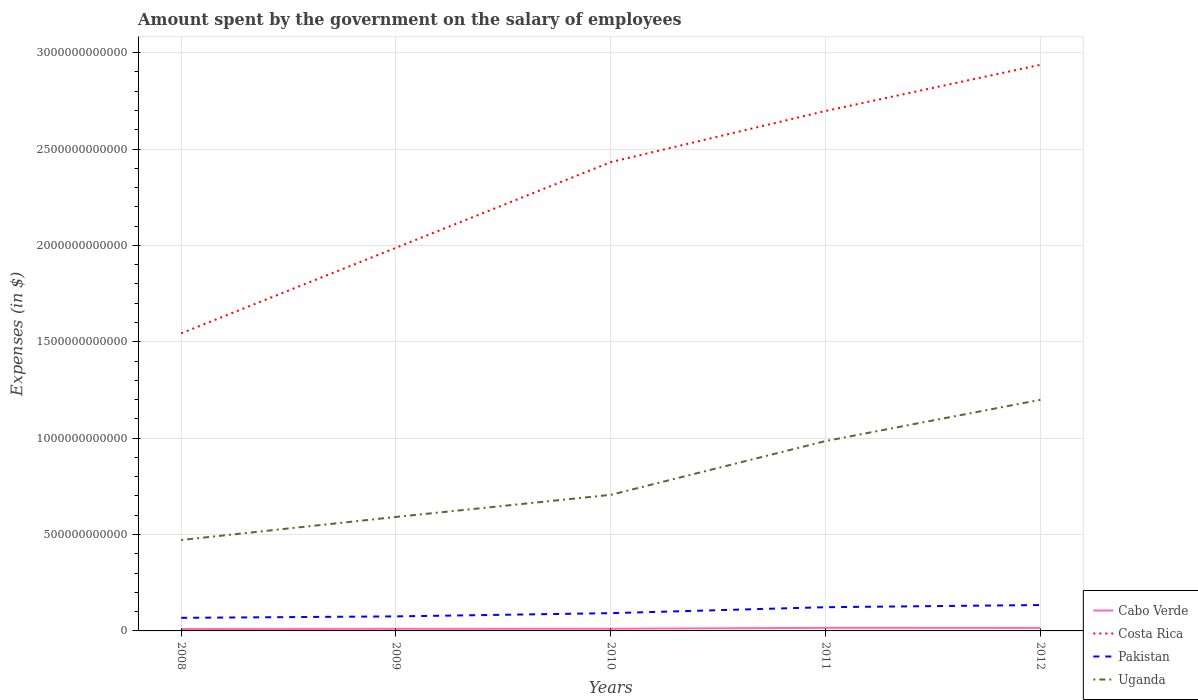How many different coloured lines are there?
Offer a very short reply. 4. Across all years, what is the maximum amount spent on the salary of employees by the government in Pakistan?
Provide a short and direct response. 6.79e+1. In which year was the amount spent on the salary of employees by the government in Costa Rica maximum?
Offer a very short reply. 2008. What is the total amount spent on the salary of employees by the government in Costa Rica in the graph?
Provide a short and direct response. -8.88e+11. What is the difference between the highest and the second highest amount spent on the salary of employees by the government in Uganda?
Give a very brief answer. 7.27e+11. Is the amount spent on the salary of employees by the government in Costa Rica strictly greater than the amount spent on the salary of employees by the government in Uganda over the years?
Offer a terse response. No. What is the difference between two consecutive major ticks on the Y-axis?
Make the answer very short. 5.00e+11. Are the values on the major ticks of Y-axis written in scientific E-notation?
Keep it short and to the point. No. Does the graph contain grids?
Your answer should be compact. Yes. Where does the legend appear in the graph?
Make the answer very short. Bottom right. How many legend labels are there?
Offer a very short reply. 4. What is the title of the graph?
Make the answer very short. Amount spent by the government on the salary of employees. Does "Morocco" appear as one of the legend labels in the graph?
Your answer should be compact. No. What is the label or title of the Y-axis?
Give a very brief answer. Expenses (in $). What is the Expenses (in $) of Cabo Verde in 2008?
Offer a terse response. 9.88e+09. What is the Expenses (in $) of Costa Rica in 2008?
Your answer should be compact. 1.54e+12. What is the Expenses (in $) in Pakistan in 2008?
Keep it short and to the point. 6.79e+1. What is the Expenses (in $) of Uganda in 2008?
Keep it short and to the point. 4.72e+11. What is the Expenses (in $) in Cabo Verde in 2009?
Offer a terse response. 1.09e+1. What is the Expenses (in $) in Costa Rica in 2009?
Ensure brevity in your answer.  1.99e+12. What is the Expenses (in $) in Pakistan in 2009?
Keep it short and to the point. 7.54e+1. What is the Expenses (in $) in Uganda in 2009?
Give a very brief answer. 5.91e+11. What is the Expenses (in $) of Cabo Verde in 2010?
Keep it short and to the point. 1.13e+1. What is the Expenses (in $) in Costa Rica in 2010?
Keep it short and to the point. 2.43e+12. What is the Expenses (in $) in Pakistan in 2010?
Your response must be concise. 9.21e+1. What is the Expenses (in $) in Uganda in 2010?
Offer a terse response. 7.06e+11. What is the Expenses (in $) in Cabo Verde in 2011?
Your answer should be very brief. 1.60e+1. What is the Expenses (in $) of Costa Rica in 2011?
Give a very brief answer. 2.70e+12. What is the Expenses (in $) in Pakistan in 2011?
Ensure brevity in your answer.  1.23e+11. What is the Expenses (in $) in Uganda in 2011?
Keep it short and to the point. 9.85e+11. What is the Expenses (in $) in Cabo Verde in 2012?
Keep it short and to the point. 1.58e+1. What is the Expenses (in $) in Costa Rica in 2012?
Your answer should be very brief. 2.94e+12. What is the Expenses (in $) of Pakistan in 2012?
Provide a short and direct response. 1.34e+11. What is the Expenses (in $) of Uganda in 2012?
Make the answer very short. 1.20e+12. Across all years, what is the maximum Expenses (in $) in Cabo Verde?
Offer a terse response. 1.60e+1. Across all years, what is the maximum Expenses (in $) of Costa Rica?
Offer a very short reply. 2.94e+12. Across all years, what is the maximum Expenses (in $) of Pakistan?
Offer a terse response. 1.34e+11. Across all years, what is the maximum Expenses (in $) in Uganda?
Ensure brevity in your answer.  1.20e+12. Across all years, what is the minimum Expenses (in $) in Cabo Verde?
Provide a succinct answer. 9.88e+09. Across all years, what is the minimum Expenses (in $) of Costa Rica?
Give a very brief answer. 1.54e+12. Across all years, what is the minimum Expenses (in $) of Pakistan?
Give a very brief answer. 6.79e+1. Across all years, what is the minimum Expenses (in $) in Uganda?
Ensure brevity in your answer.  4.72e+11. What is the total Expenses (in $) of Cabo Verde in the graph?
Offer a terse response. 6.38e+1. What is the total Expenses (in $) of Costa Rica in the graph?
Offer a very short reply. 1.16e+13. What is the total Expenses (in $) in Pakistan in the graph?
Offer a terse response. 4.93e+11. What is the total Expenses (in $) in Uganda in the graph?
Your response must be concise. 3.95e+12. What is the difference between the Expenses (in $) in Cabo Verde in 2008 and that in 2009?
Offer a very short reply. -9.92e+08. What is the difference between the Expenses (in $) of Costa Rica in 2008 and that in 2009?
Your answer should be very brief. -4.44e+11. What is the difference between the Expenses (in $) in Pakistan in 2008 and that in 2009?
Ensure brevity in your answer.  -7.49e+09. What is the difference between the Expenses (in $) in Uganda in 2008 and that in 2009?
Your response must be concise. -1.20e+11. What is the difference between the Expenses (in $) in Cabo Verde in 2008 and that in 2010?
Your answer should be compact. -1.42e+09. What is the difference between the Expenses (in $) in Costa Rica in 2008 and that in 2010?
Your response must be concise. -8.88e+11. What is the difference between the Expenses (in $) in Pakistan in 2008 and that in 2010?
Your answer should be very brief. -2.42e+1. What is the difference between the Expenses (in $) in Uganda in 2008 and that in 2010?
Make the answer very short. -2.34e+11. What is the difference between the Expenses (in $) of Cabo Verde in 2008 and that in 2011?
Give a very brief answer. -6.12e+09. What is the difference between the Expenses (in $) of Costa Rica in 2008 and that in 2011?
Your answer should be compact. -1.15e+12. What is the difference between the Expenses (in $) in Pakistan in 2008 and that in 2011?
Your answer should be very brief. -5.52e+1. What is the difference between the Expenses (in $) in Uganda in 2008 and that in 2011?
Offer a terse response. -5.13e+11. What is the difference between the Expenses (in $) of Cabo Verde in 2008 and that in 2012?
Make the answer very short. -5.88e+09. What is the difference between the Expenses (in $) of Costa Rica in 2008 and that in 2012?
Offer a very short reply. -1.39e+12. What is the difference between the Expenses (in $) of Pakistan in 2008 and that in 2012?
Make the answer very short. -6.64e+1. What is the difference between the Expenses (in $) in Uganda in 2008 and that in 2012?
Your response must be concise. -7.27e+11. What is the difference between the Expenses (in $) in Cabo Verde in 2009 and that in 2010?
Provide a succinct answer. -4.29e+08. What is the difference between the Expenses (in $) in Costa Rica in 2009 and that in 2010?
Offer a terse response. -4.44e+11. What is the difference between the Expenses (in $) in Pakistan in 2009 and that in 2010?
Offer a terse response. -1.67e+1. What is the difference between the Expenses (in $) in Uganda in 2009 and that in 2010?
Provide a succinct answer. -1.15e+11. What is the difference between the Expenses (in $) of Cabo Verde in 2009 and that in 2011?
Offer a terse response. -5.12e+09. What is the difference between the Expenses (in $) in Costa Rica in 2009 and that in 2011?
Your answer should be compact. -7.10e+11. What is the difference between the Expenses (in $) of Pakistan in 2009 and that in 2011?
Your answer should be very brief. -4.77e+1. What is the difference between the Expenses (in $) of Uganda in 2009 and that in 2011?
Keep it short and to the point. -3.94e+11. What is the difference between the Expenses (in $) of Cabo Verde in 2009 and that in 2012?
Offer a terse response. -4.88e+09. What is the difference between the Expenses (in $) in Costa Rica in 2009 and that in 2012?
Offer a terse response. -9.49e+11. What is the difference between the Expenses (in $) of Pakistan in 2009 and that in 2012?
Provide a short and direct response. -5.89e+1. What is the difference between the Expenses (in $) in Uganda in 2009 and that in 2012?
Ensure brevity in your answer.  -6.08e+11. What is the difference between the Expenses (in $) of Cabo Verde in 2010 and that in 2011?
Ensure brevity in your answer.  -4.70e+09. What is the difference between the Expenses (in $) in Costa Rica in 2010 and that in 2011?
Provide a short and direct response. -2.65e+11. What is the difference between the Expenses (in $) of Pakistan in 2010 and that in 2011?
Make the answer very short. -3.10e+1. What is the difference between the Expenses (in $) of Uganda in 2010 and that in 2011?
Give a very brief answer. -2.79e+11. What is the difference between the Expenses (in $) of Cabo Verde in 2010 and that in 2012?
Your answer should be compact. -4.45e+09. What is the difference between the Expenses (in $) of Costa Rica in 2010 and that in 2012?
Keep it short and to the point. -5.05e+11. What is the difference between the Expenses (in $) of Pakistan in 2010 and that in 2012?
Make the answer very short. -4.22e+1. What is the difference between the Expenses (in $) of Uganda in 2010 and that in 2012?
Your response must be concise. -4.93e+11. What is the difference between the Expenses (in $) in Cabo Verde in 2011 and that in 2012?
Offer a terse response. 2.40e+08. What is the difference between the Expenses (in $) in Costa Rica in 2011 and that in 2012?
Your answer should be compact. -2.40e+11. What is the difference between the Expenses (in $) of Pakistan in 2011 and that in 2012?
Your answer should be very brief. -1.12e+1. What is the difference between the Expenses (in $) of Uganda in 2011 and that in 2012?
Your response must be concise. -2.14e+11. What is the difference between the Expenses (in $) of Cabo Verde in 2008 and the Expenses (in $) of Costa Rica in 2009?
Offer a terse response. -1.98e+12. What is the difference between the Expenses (in $) in Cabo Verde in 2008 and the Expenses (in $) in Pakistan in 2009?
Make the answer very short. -6.55e+1. What is the difference between the Expenses (in $) in Cabo Verde in 2008 and the Expenses (in $) in Uganda in 2009?
Keep it short and to the point. -5.81e+11. What is the difference between the Expenses (in $) in Costa Rica in 2008 and the Expenses (in $) in Pakistan in 2009?
Make the answer very short. 1.47e+12. What is the difference between the Expenses (in $) of Costa Rica in 2008 and the Expenses (in $) of Uganda in 2009?
Your answer should be very brief. 9.53e+11. What is the difference between the Expenses (in $) in Pakistan in 2008 and the Expenses (in $) in Uganda in 2009?
Your answer should be very brief. -5.23e+11. What is the difference between the Expenses (in $) in Cabo Verde in 2008 and the Expenses (in $) in Costa Rica in 2010?
Your answer should be compact. -2.42e+12. What is the difference between the Expenses (in $) in Cabo Verde in 2008 and the Expenses (in $) in Pakistan in 2010?
Give a very brief answer. -8.22e+1. What is the difference between the Expenses (in $) in Cabo Verde in 2008 and the Expenses (in $) in Uganda in 2010?
Offer a terse response. -6.96e+11. What is the difference between the Expenses (in $) of Costa Rica in 2008 and the Expenses (in $) of Pakistan in 2010?
Make the answer very short. 1.45e+12. What is the difference between the Expenses (in $) of Costa Rica in 2008 and the Expenses (in $) of Uganda in 2010?
Keep it short and to the point. 8.38e+11. What is the difference between the Expenses (in $) in Pakistan in 2008 and the Expenses (in $) in Uganda in 2010?
Offer a very short reply. -6.38e+11. What is the difference between the Expenses (in $) of Cabo Verde in 2008 and the Expenses (in $) of Costa Rica in 2011?
Ensure brevity in your answer.  -2.69e+12. What is the difference between the Expenses (in $) in Cabo Verde in 2008 and the Expenses (in $) in Pakistan in 2011?
Make the answer very short. -1.13e+11. What is the difference between the Expenses (in $) in Cabo Verde in 2008 and the Expenses (in $) in Uganda in 2011?
Give a very brief answer. -9.75e+11. What is the difference between the Expenses (in $) in Costa Rica in 2008 and the Expenses (in $) in Pakistan in 2011?
Your response must be concise. 1.42e+12. What is the difference between the Expenses (in $) in Costa Rica in 2008 and the Expenses (in $) in Uganda in 2011?
Provide a short and direct response. 5.59e+11. What is the difference between the Expenses (in $) of Pakistan in 2008 and the Expenses (in $) of Uganda in 2011?
Give a very brief answer. -9.17e+11. What is the difference between the Expenses (in $) of Cabo Verde in 2008 and the Expenses (in $) of Costa Rica in 2012?
Make the answer very short. -2.93e+12. What is the difference between the Expenses (in $) of Cabo Verde in 2008 and the Expenses (in $) of Pakistan in 2012?
Make the answer very short. -1.24e+11. What is the difference between the Expenses (in $) of Cabo Verde in 2008 and the Expenses (in $) of Uganda in 2012?
Offer a terse response. -1.19e+12. What is the difference between the Expenses (in $) in Costa Rica in 2008 and the Expenses (in $) in Pakistan in 2012?
Offer a terse response. 1.41e+12. What is the difference between the Expenses (in $) in Costa Rica in 2008 and the Expenses (in $) in Uganda in 2012?
Offer a very short reply. 3.45e+11. What is the difference between the Expenses (in $) of Pakistan in 2008 and the Expenses (in $) of Uganda in 2012?
Your answer should be compact. -1.13e+12. What is the difference between the Expenses (in $) in Cabo Verde in 2009 and the Expenses (in $) in Costa Rica in 2010?
Give a very brief answer. -2.42e+12. What is the difference between the Expenses (in $) of Cabo Verde in 2009 and the Expenses (in $) of Pakistan in 2010?
Offer a terse response. -8.12e+1. What is the difference between the Expenses (in $) of Cabo Verde in 2009 and the Expenses (in $) of Uganda in 2010?
Offer a very short reply. -6.95e+11. What is the difference between the Expenses (in $) in Costa Rica in 2009 and the Expenses (in $) in Pakistan in 2010?
Your answer should be compact. 1.90e+12. What is the difference between the Expenses (in $) in Costa Rica in 2009 and the Expenses (in $) in Uganda in 2010?
Offer a very short reply. 1.28e+12. What is the difference between the Expenses (in $) in Pakistan in 2009 and the Expenses (in $) in Uganda in 2010?
Your answer should be compact. -6.31e+11. What is the difference between the Expenses (in $) in Cabo Verde in 2009 and the Expenses (in $) in Costa Rica in 2011?
Make the answer very short. -2.69e+12. What is the difference between the Expenses (in $) of Cabo Verde in 2009 and the Expenses (in $) of Pakistan in 2011?
Ensure brevity in your answer.  -1.12e+11. What is the difference between the Expenses (in $) of Cabo Verde in 2009 and the Expenses (in $) of Uganda in 2011?
Keep it short and to the point. -9.74e+11. What is the difference between the Expenses (in $) of Costa Rica in 2009 and the Expenses (in $) of Pakistan in 2011?
Provide a succinct answer. 1.86e+12. What is the difference between the Expenses (in $) in Costa Rica in 2009 and the Expenses (in $) in Uganda in 2011?
Give a very brief answer. 1.00e+12. What is the difference between the Expenses (in $) in Pakistan in 2009 and the Expenses (in $) in Uganda in 2011?
Offer a terse response. -9.10e+11. What is the difference between the Expenses (in $) of Cabo Verde in 2009 and the Expenses (in $) of Costa Rica in 2012?
Provide a succinct answer. -2.93e+12. What is the difference between the Expenses (in $) in Cabo Verde in 2009 and the Expenses (in $) in Pakistan in 2012?
Your answer should be very brief. -1.23e+11. What is the difference between the Expenses (in $) in Cabo Verde in 2009 and the Expenses (in $) in Uganda in 2012?
Ensure brevity in your answer.  -1.19e+12. What is the difference between the Expenses (in $) of Costa Rica in 2009 and the Expenses (in $) of Pakistan in 2012?
Give a very brief answer. 1.85e+12. What is the difference between the Expenses (in $) in Costa Rica in 2009 and the Expenses (in $) in Uganda in 2012?
Ensure brevity in your answer.  7.89e+11. What is the difference between the Expenses (in $) of Pakistan in 2009 and the Expenses (in $) of Uganda in 2012?
Offer a terse response. -1.12e+12. What is the difference between the Expenses (in $) of Cabo Verde in 2010 and the Expenses (in $) of Costa Rica in 2011?
Provide a short and direct response. -2.69e+12. What is the difference between the Expenses (in $) of Cabo Verde in 2010 and the Expenses (in $) of Pakistan in 2011?
Provide a succinct answer. -1.12e+11. What is the difference between the Expenses (in $) in Cabo Verde in 2010 and the Expenses (in $) in Uganda in 2011?
Your answer should be very brief. -9.74e+11. What is the difference between the Expenses (in $) in Costa Rica in 2010 and the Expenses (in $) in Pakistan in 2011?
Give a very brief answer. 2.31e+12. What is the difference between the Expenses (in $) in Costa Rica in 2010 and the Expenses (in $) in Uganda in 2011?
Offer a terse response. 1.45e+12. What is the difference between the Expenses (in $) of Pakistan in 2010 and the Expenses (in $) of Uganda in 2011?
Ensure brevity in your answer.  -8.93e+11. What is the difference between the Expenses (in $) of Cabo Verde in 2010 and the Expenses (in $) of Costa Rica in 2012?
Give a very brief answer. -2.93e+12. What is the difference between the Expenses (in $) in Cabo Verde in 2010 and the Expenses (in $) in Pakistan in 2012?
Make the answer very short. -1.23e+11. What is the difference between the Expenses (in $) of Cabo Verde in 2010 and the Expenses (in $) of Uganda in 2012?
Give a very brief answer. -1.19e+12. What is the difference between the Expenses (in $) in Costa Rica in 2010 and the Expenses (in $) in Pakistan in 2012?
Offer a very short reply. 2.30e+12. What is the difference between the Expenses (in $) of Costa Rica in 2010 and the Expenses (in $) of Uganda in 2012?
Keep it short and to the point. 1.23e+12. What is the difference between the Expenses (in $) in Pakistan in 2010 and the Expenses (in $) in Uganda in 2012?
Offer a very short reply. -1.11e+12. What is the difference between the Expenses (in $) in Cabo Verde in 2011 and the Expenses (in $) in Costa Rica in 2012?
Your answer should be very brief. -2.92e+12. What is the difference between the Expenses (in $) in Cabo Verde in 2011 and the Expenses (in $) in Pakistan in 2012?
Ensure brevity in your answer.  -1.18e+11. What is the difference between the Expenses (in $) in Cabo Verde in 2011 and the Expenses (in $) in Uganda in 2012?
Your answer should be compact. -1.18e+12. What is the difference between the Expenses (in $) in Costa Rica in 2011 and the Expenses (in $) in Pakistan in 2012?
Keep it short and to the point. 2.56e+12. What is the difference between the Expenses (in $) of Costa Rica in 2011 and the Expenses (in $) of Uganda in 2012?
Provide a succinct answer. 1.50e+12. What is the difference between the Expenses (in $) of Pakistan in 2011 and the Expenses (in $) of Uganda in 2012?
Keep it short and to the point. -1.08e+12. What is the average Expenses (in $) in Cabo Verde per year?
Provide a short and direct response. 1.28e+1. What is the average Expenses (in $) in Costa Rica per year?
Your answer should be compact. 2.32e+12. What is the average Expenses (in $) in Pakistan per year?
Provide a succinct answer. 9.86e+1. What is the average Expenses (in $) of Uganda per year?
Give a very brief answer. 7.91e+11. In the year 2008, what is the difference between the Expenses (in $) in Cabo Verde and Expenses (in $) in Costa Rica?
Offer a very short reply. -1.53e+12. In the year 2008, what is the difference between the Expenses (in $) of Cabo Verde and Expenses (in $) of Pakistan?
Your response must be concise. -5.80e+1. In the year 2008, what is the difference between the Expenses (in $) in Cabo Verde and Expenses (in $) in Uganda?
Give a very brief answer. -4.62e+11. In the year 2008, what is the difference between the Expenses (in $) of Costa Rica and Expenses (in $) of Pakistan?
Your answer should be compact. 1.48e+12. In the year 2008, what is the difference between the Expenses (in $) of Costa Rica and Expenses (in $) of Uganda?
Provide a succinct answer. 1.07e+12. In the year 2008, what is the difference between the Expenses (in $) of Pakistan and Expenses (in $) of Uganda?
Offer a terse response. -4.04e+11. In the year 2009, what is the difference between the Expenses (in $) in Cabo Verde and Expenses (in $) in Costa Rica?
Make the answer very short. -1.98e+12. In the year 2009, what is the difference between the Expenses (in $) of Cabo Verde and Expenses (in $) of Pakistan?
Offer a terse response. -6.45e+1. In the year 2009, what is the difference between the Expenses (in $) of Cabo Verde and Expenses (in $) of Uganda?
Give a very brief answer. -5.80e+11. In the year 2009, what is the difference between the Expenses (in $) in Costa Rica and Expenses (in $) in Pakistan?
Ensure brevity in your answer.  1.91e+12. In the year 2009, what is the difference between the Expenses (in $) in Costa Rica and Expenses (in $) in Uganda?
Provide a succinct answer. 1.40e+12. In the year 2009, what is the difference between the Expenses (in $) in Pakistan and Expenses (in $) in Uganda?
Your answer should be very brief. -5.16e+11. In the year 2010, what is the difference between the Expenses (in $) in Cabo Verde and Expenses (in $) in Costa Rica?
Ensure brevity in your answer.  -2.42e+12. In the year 2010, what is the difference between the Expenses (in $) of Cabo Verde and Expenses (in $) of Pakistan?
Your answer should be compact. -8.08e+1. In the year 2010, what is the difference between the Expenses (in $) of Cabo Verde and Expenses (in $) of Uganda?
Make the answer very short. -6.95e+11. In the year 2010, what is the difference between the Expenses (in $) in Costa Rica and Expenses (in $) in Pakistan?
Give a very brief answer. 2.34e+12. In the year 2010, what is the difference between the Expenses (in $) of Costa Rica and Expenses (in $) of Uganda?
Make the answer very short. 1.73e+12. In the year 2010, what is the difference between the Expenses (in $) of Pakistan and Expenses (in $) of Uganda?
Make the answer very short. -6.14e+11. In the year 2011, what is the difference between the Expenses (in $) of Cabo Verde and Expenses (in $) of Costa Rica?
Offer a very short reply. -2.68e+12. In the year 2011, what is the difference between the Expenses (in $) of Cabo Verde and Expenses (in $) of Pakistan?
Your response must be concise. -1.07e+11. In the year 2011, what is the difference between the Expenses (in $) in Cabo Verde and Expenses (in $) in Uganda?
Your answer should be very brief. -9.69e+11. In the year 2011, what is the difference between the Expenses (in $) of Costa Rica and Expenses (in $) of Pakistan?
Keep it short and to the point. 2.57e+12. In the year 2011, what is the difference between the Expenses (in $) of Costa Rica and Expenses (in $) of Uganda?
Give a very brief answer. 1.71e+12. In the year 2011, what is the difference between the Expenses (in $) in Pakistan and Expenses (in $) in Uganda?
Offer a terse response. -8.62e+11. In the year 2012, what is the difference between the Expenses (in $) in Cabo Verde and Expenses (in $) in Costa Rica?
Your answer should be very brief. -2.92e+12. In the year 2012, what is the difference between the Expenses (in $) in Cabo Verde and Expenses (in $) in Pakistan?
Your response must be concise. -1.19e+11. In the year 2012, what is the difference between the Expenses (in $) of Cabo Verde and Expenses (in $) of Uganda?
Your answer should be compact. -1.18e+12. In the year 2012, what is the difference between the Expenses (in $) of Costa Rica and Expenses (in $) of Pakistan?
Your answer should be compact. 2.80e+12. In the year 2012, what is the difference between the Expenses (in $) in Costa Rica and Expenses (in $) in Uganda?
Your answer should be compact. 1.74e+12. In the year 2012, what is the difference between the Expenses (in $) of Pakistan and Expenses (in $) of Uganda?
Your response must be concise. -1.06e+12. What is the ratio of the Expenses (in $) of Cabo Verde in 2008 to that in 2009?
Provide a short and direct response. 0.91. What is the ratio of the Expenses (in $) of Costa Rica in 2008 to that in 2009?
Provide a short and direct response. 0.78. What is the ratio of the Expenses (in $) in Pakistan in 2008 to that in 2009?
Your answer should be compact. 0.9. What is the ratio of the Expenses (in $) in Uganda in 2008 to that in 2009?
Offer a very short reply. 0.8. What is the ratio of the Expenses (in $) in Cabo Verde in 2008 to that in 2010?
Provide a short and direct response. 0.87. What is the ratio of the Expenses (in $) of Costa Rica in 2008 to that in 2010?
Your answer should be very brief. 0.63. What is the ratio of the Expenses (in $) of Pakistan in 2008 to that in 2010?
Your response must be concise. 0.74. What is the ratio of the Expenses (in $) of Uganda in 2008 to that in 2010?
Your answer should be very brief. 0.67. What is the ratio of the Expenses (in $) of Cabo Verde in 2008 to that in 2011?
Make the answer very short. 0.62. What is the ratio of the Expenses (in $) in Costa Rica in 2008 to that in 2011?
Your answer should be very brief. 0.57. What is the ratio of the Expenses (in $) in Pakistan in 2008 to that in 2011?
Provide a succinct answer. 0.55. What is the ratio of the Expenses (in $) of Uganda in 2008 to that in 2011?
Ensure brevity in your answer.  0.48. What is the ratio of the Expenses (in $) in Cabo Verde in 2008 to that in 2012?
Provide a short and direct response. 0.63. What is the ratio of the Expenses (in $) in Costa Rica in 2008 to that in 2012?
Offer a terse response. 0.53. What is the ratio of the Expenses (in $) of Pakistan in 2008 to that in 2012?
Give a very brief answer. 0.51. What is the ratio of the Expenses (in $) in Uganda in 2008 to that in 2012?
Keep it short and to the point. 0.39. What is the ratio of the Expenses (in $) of Cabo Verde in 2009 to that in 2010?
Offer a terse response. 0.96. What is the ratio of the Expenses (in $) of Costa Rica in 2009 to that in 2010?
Your answer should be compact. 0.82. What is the ratio of the Expenses (in $) in Pakistan in 2009 to that in 2010?
Your answer should be compact. 0.82. What is the ratio of the Expenses (in $) in Uganda in 2009 to that in 2010?
Make the answer very short. 0.84. What is the ratio of the Expenses (in $) in Cabo Verde in 2009 to that in 2011?
Your answer should be very brief. 0.68. What is the ratio of the Expenses (in $) of Costa Rica in 2009 to that in 2011?
Provide a short and direct response. 0.74. What is the ratio of the Expenses (in $) of Pakistan in 2009 to that in 2011?
Provide a succinct answer. 0.61. What is the ratio of the Expenses (in $) of Uganda in 2009 to that in 2011?
Provide a succinct answer. 0.6. What is the ratio of the Expenses (in $) of Cabo Verde in 2009 to that in 2012?
Your response must be concise. 0.69. What is the ratio of the Expenses (in $) of Costa Rica in 2009 to that in 2012?
Provide a succinct answer. 0.68. What is the ratio of the Expenses (in $) in Pakistan in 2009 to that in 2012?
Provide a short and direct response. 0.56. What is the ratio of the Expenses (in $) in Uganda in 2009 to that in 2012?
Give a very brief answer. 0.49. What is the ratio of the Expenses (in $) of Cabo Verde in 2010 to that in 2011?
Your response must be concise. 0.71. What is the ratio of the Expenses (in $) of Costa Rica in 2010 to that in 2011?
Your answer should be very brief. 0.9. What is the ratio of the Expenses (in $) in Pakistan in 2010 to that in 2011?
Ensure brevity in your answer.  0.75. What is the ratio of the Expenses (in $) of Uganda in 2010 to that in 2011?
Your answer should be very brief. 0.72. What is the ratio of the Expenses (in $) in Cabo Verde in 2010 to that in 2012?
Provide a short and direct response. 0.72. What is the ratio of the Expenses (in $) in Costa Rica in 2010 to that in 2012?
Provide a short and direct response. 0.83. What is the ratio of the Expenses (in $) in Pakistan in 2010 to that in 2012?
Offer a very short reply. 0.69. What is the ratio of the Expenses (in $) in Uganda in 2010 to that in 2012?
Keep it short and to the point. 0.59. What is the ratio of the Expenses (in $) in Cabo Verde in 2011 to that in 2012?
Offer a very short reply. 1.02. What is the ratio of the Expenses (in $) of Costa Rica in 2011 to that in 2012?
Provide a short and direct response. 0.92. What is the ratio of the Expenses (in $) of Pakistan in 2011 to that in 2012?
Provide a short and direct response. 0.92. What is the ratio of the Expenses (in $) in Uganda in 2011 to that in 2012?
Provide a succinct answer. 0.82. What is the difference between the highest and the second highest Expenses (in $) in Cabo Verde?
Your answer should be very brief. 2.40e+08. What is the difference between the highest and the second highest Expenses (in $) of Costa Rica?
Your response must be concise. 2.40e+11. What is the difference between the highest and the second highest Expenses (in $) in Pakistan?
Make the answer very short. 1.12e+1. What is the difference between the highest and the second highest Expenses (in $) of Uganda?
Offer a very short reply. 2.14e+11. What is the difference between the highest and the lowest Expenses (in $) of Cabo Verde?
Keep it short and to the point. 6.12e+09. What is the difference between the highest and the lowest Expenses (in $) of Costa Rica?
Offer a very short reply. 1.39e+12. What is the difference between the highest and the lowest Expenses (in $) of Pakistan?
Keep it short and to the point. 6.64e+1. What is the difference between the highest and the lowest Expenses (in $) of Uganda?
Your answer should be very brief. 7.27e+11. 